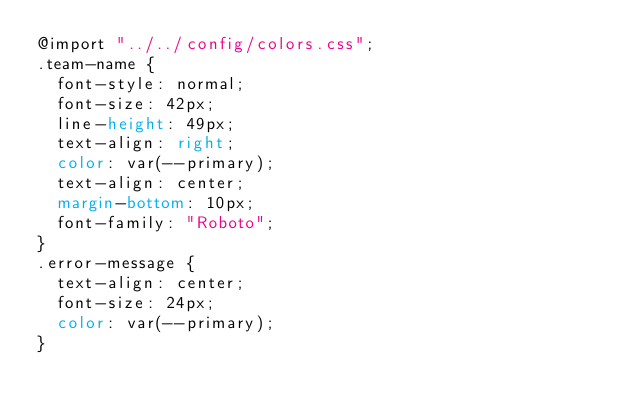<code> <loc_0><loc_0><loc_500><loc_500><_CSS_>@import "../../config/colors.css";
.team-name {
  font-style: normal;
  font-size: 42px;
  line-height: 49px;
  text-align: right;
  color: var(--primary);
  text-align: center;
  margin-bottom: 10px;
  font-family: "Roboto";
}
.error-message {
  text-align: center;
  font-size: 24px;
  color: var(--primary);
}
</code> 